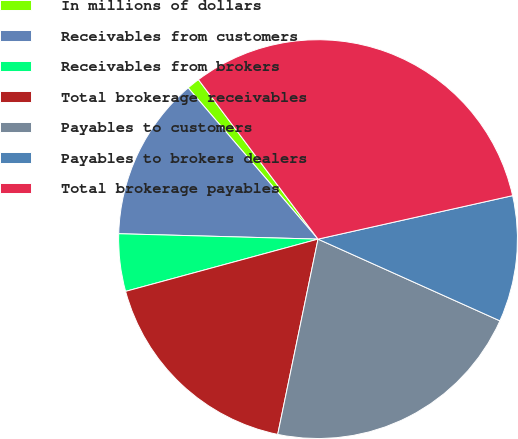Convert chart to OTSL. <chart><loc_0><loc_0><loc_500><loc_500><pie_chart><fcel>In millions of dollars<fcel>Receivables from customers<fcel>Receivables from brokers<fcel>Total brokerage receivables<fcel>Payables to customers<fcel>Payables to brokers dealers<fcel>Total brokerage payables<nl><fcel>1.05%<fcel>13.28%<fcel>4.65%<fcel>17.54%<fcel>21.52%<fcel>10.22%<fcel>31.74%<nl></chart> 